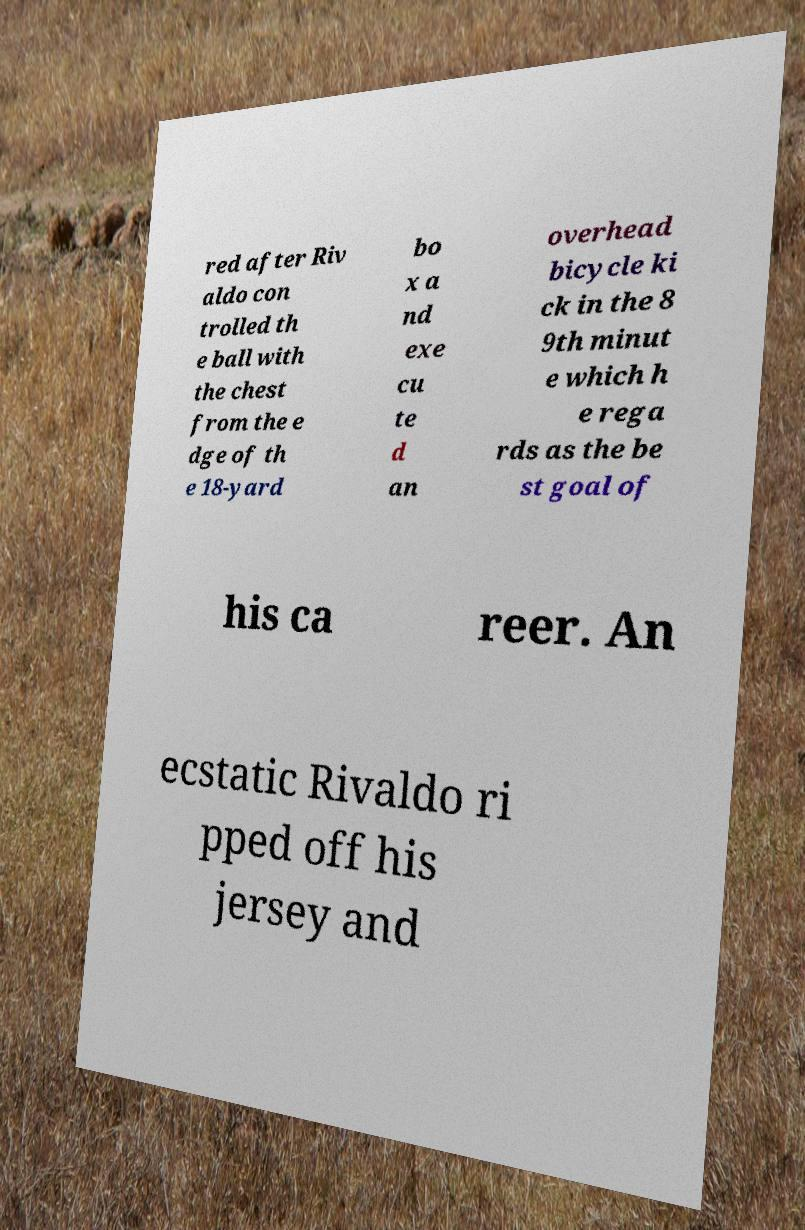Please read and relay the text visible in this image. What does it say? red after Riv aldo con trolled th e ball with the chest from the e dge of th e 18-yard bo x a nd exe cu te d an overhead bicycle ki ck in the 8 9th minut e which h e rega rds as the be st goal of his ca reer. An ecstatic Rivaldo ri pped off his jersey and 